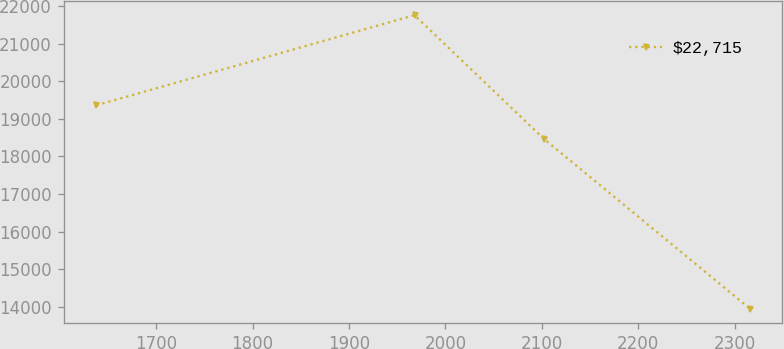Convert chart. <chart><loc_0><loc_0><loc_500><loc_500><line_chart><ecel><fcel>$22,715<nl><fcel>1637.92<fcel>19360.2<nl><fcel>1967.95<fcel>21753.4<nl><fcel>2102.17<fcel>18467<nl><fcel>2315.71<fcel>13959.2<nl></chart> 